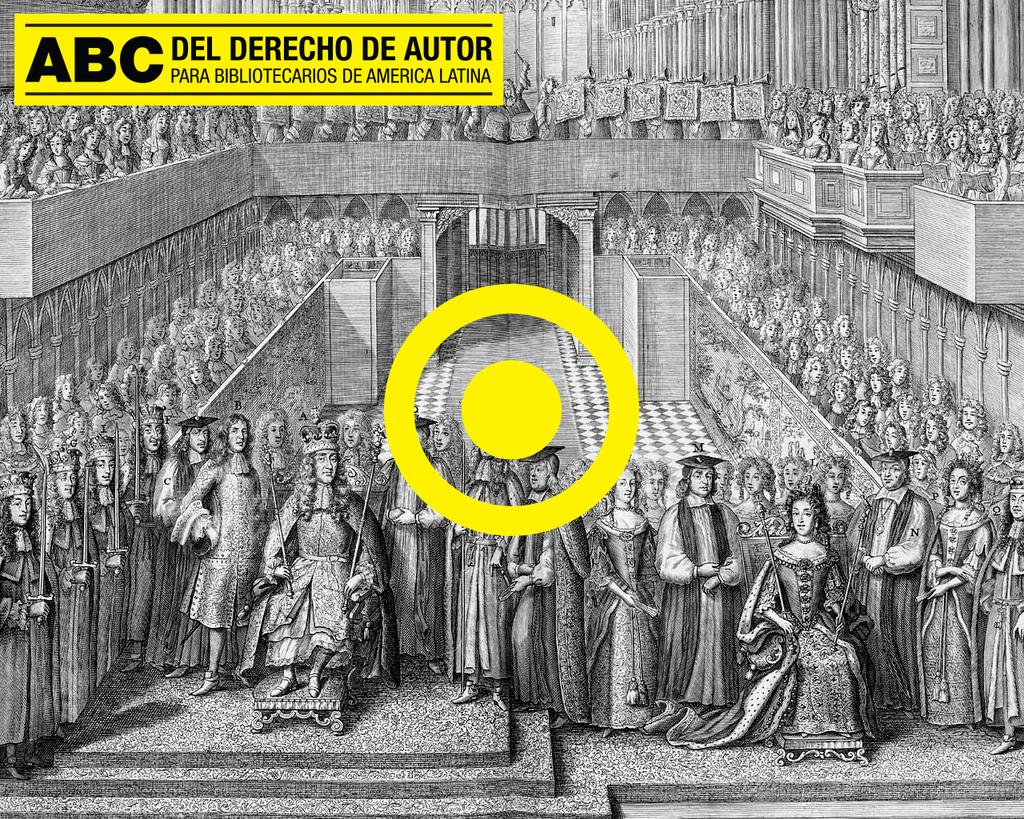What type of visual is the image? The image appears to be a poster. What is the main subject of the poster? The poster contains a painting of a crowd of people. What other elements are present in the image? There is a building depicted in the image. Is there any text on the poster? Yes, there is some text at the top of the image. Where is the goat located in the image? There is no goat present in the image. How does the poster maintain a quiet atmosphere? The poster does not have any audible elements, so it cannot maintain a quiet atmosphere. 